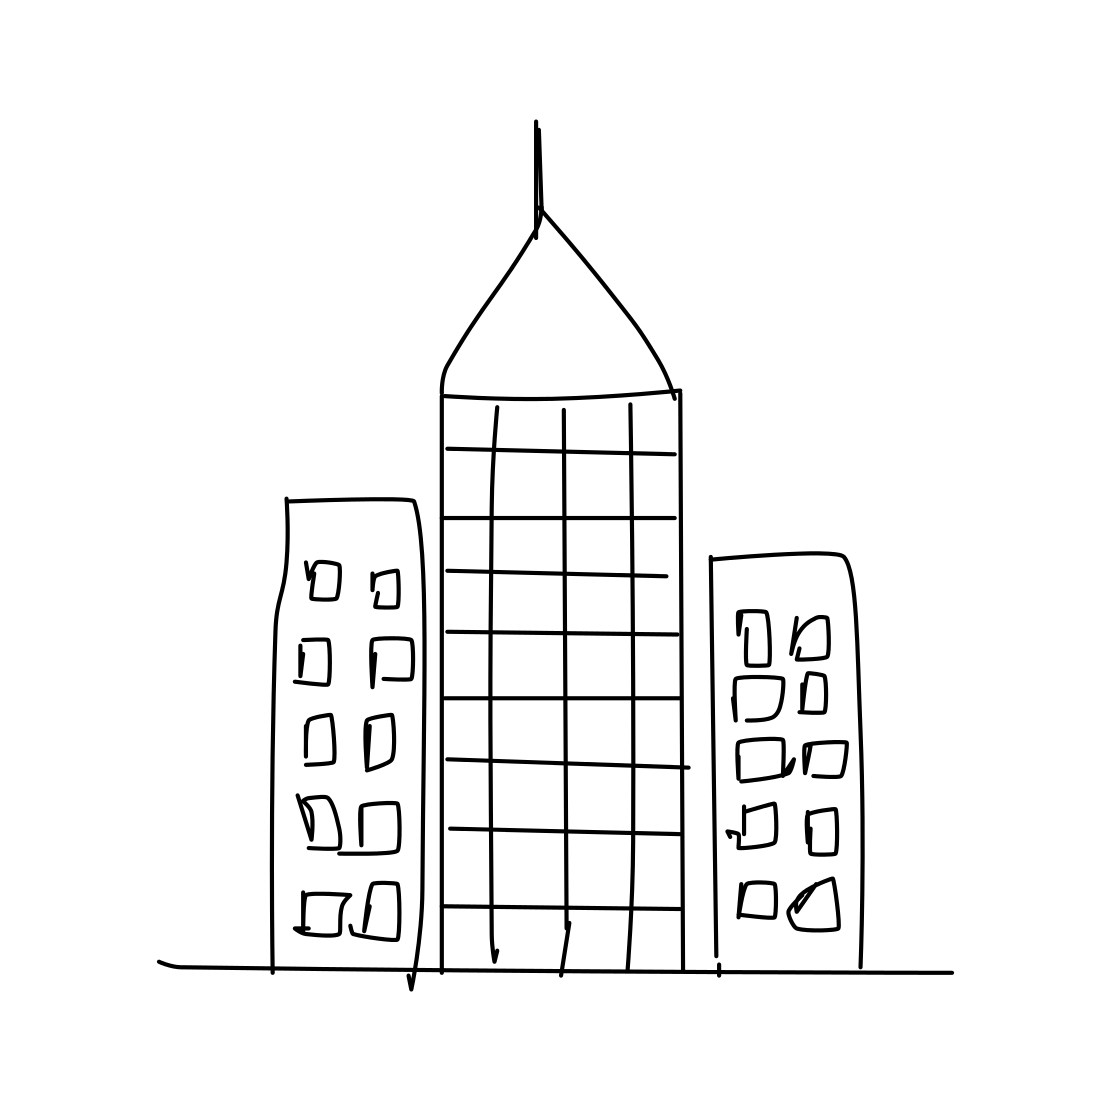Could this sketch be part of a storyboard for a movie? If so, what genre? Yes, this sketch could certainly be part of a storyboard for a movie, possibly serving as the backdrop for a science fiction or dystopian genre film, where the simplistic nature of the art can reflect a futuristic or alternative reality. 